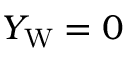Convert formula to latex. <formula><loc_0><loc_0><loc_500><loc_500>Y _ { W } = 0</formula> 